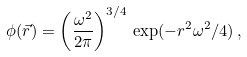<formula> <loc_0><loc_0><loc_500><loc_500>\phi ( \vec { r } ) = \left ( \frac { \omega ^ { 2 } } { 2 \pi } \right ) ^ { 3 / 4 } \, \exp ( - r ^ { 2 } \omega ^ { 2 } / 4 ) \, ,</formula> 